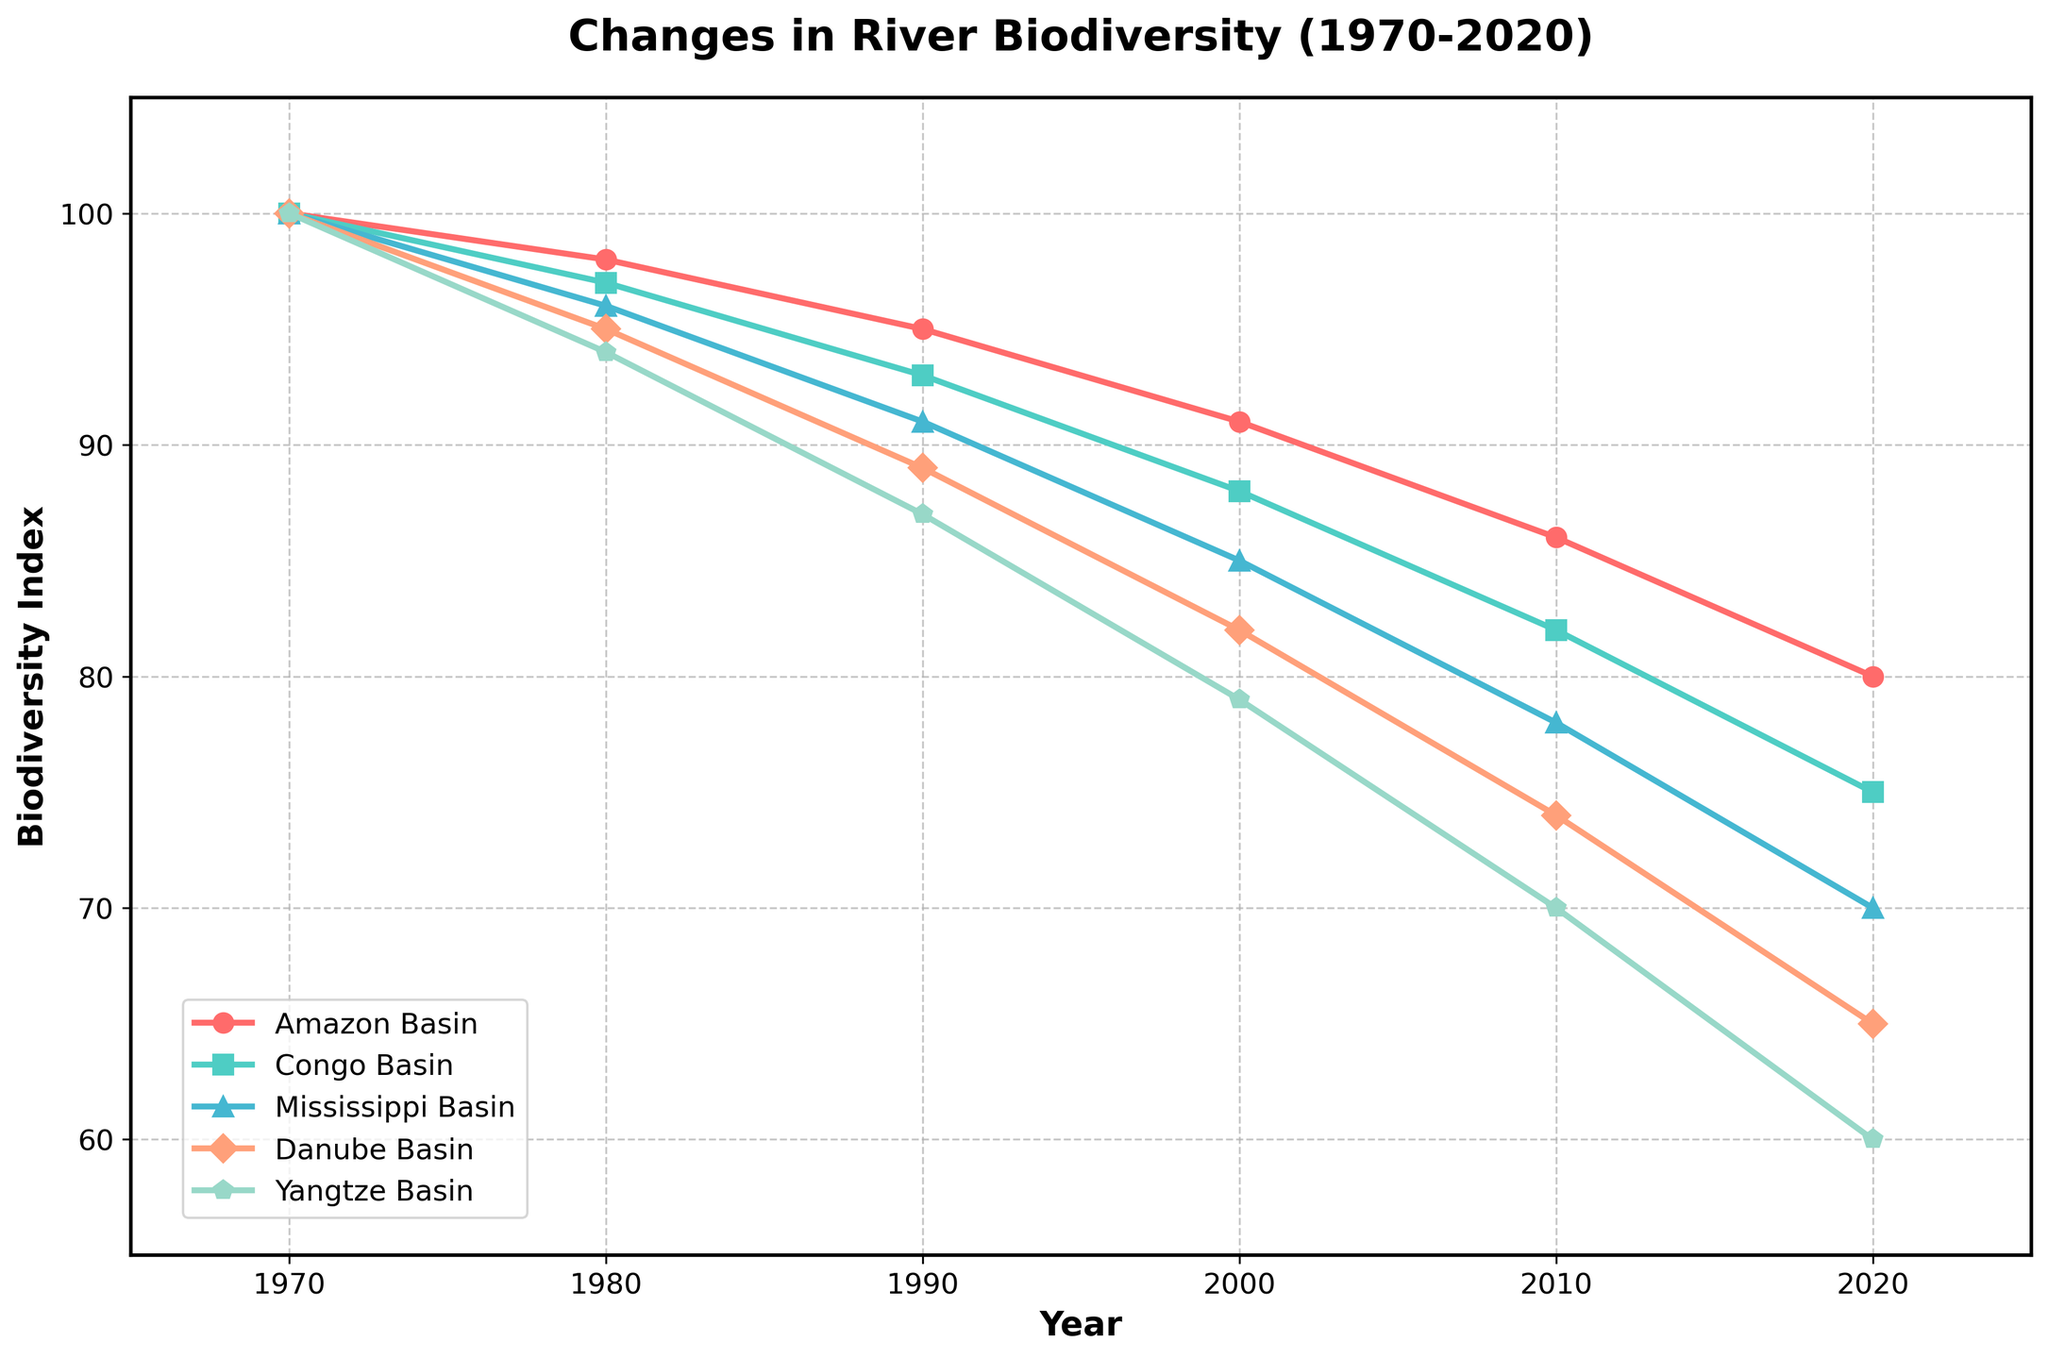How has the biodiversity index of the Amazon Basin changed from 1970 to 2020? The biodiversity index of the Amazon Basin starts at 100 in 1970 and drops to 80 by 2020. The values can be observed directly from the figure, showing a decrease of 20 over the 50 years.
Answer: Decreased by 20 Which river basin experienced the largest decrease in biodiversity over the last 50 years? To find the largest decrease, compare the 1970 and 2020 values for each river basin. The Amazon Basin decreased from 100 to 80, the Congo Basin from 100 to 75, the Mississippi Basin from 100 to 70, the Danube Basin from 100 to 65, and the Yangtze Basin from 100 to 60. The Yangtze Basin has the largest decrease (40).
Answer: Yangtze Basin Between which years did the Congo Basin's biodiversity index experience its steepest decline? To determine the steepest decline, calculate the differences between consecutive years for the Congo Basin: 100 to 97 (-3), 97 to 93 (-4), 93 to 88 (-5), 88 to 82 (-6), 82 to 75 (-7). The steepest decline happened between 2010 and 2020 (-7).
Answer: 2010 to 2020 Which river basin had the highest biodiversity index in 1990? To find this, check the biodiversity indexes for 1990. Amazon Basin (95), Congo Basin (93), Mississippi Basin (91), Danube Basin (89), and Yangtze Basin (87). The Amazon Basin had the highest index (95).
Answer: Amazon Basin On average, how much did the biodiversity index of the Danube Basin decrease each decade? Compute the total decrease from 1970 to 2020 for the Danube Basin: from 100 to 65, a decrease of 35 points. Over 5 decades, the average decrease per decade is 35 / 5 = 7.
Answer: 7 By what percentage did the biodiversity index of the Yangtze Basin decrease from 1970 to 2020? Calculate the percentage decrease with the formula [(initial value - final value) / initial value] * 100. For the Yangtze Basin: [(100 - 60) / 100] * 100 = 40%.
Answer: 40% During which decade did the Mississippi Basin experience the smallest decrease in biodiversity? Calculate the decreases: 100 to 96 (-4), 96 to 91 (-5), 91 to 85 (-6), 85 to 78 (-7), 78 to 70 (-8). The smallest decrease was between 1970 and 1980 (-4 points).
Answer: 1970 to 1980 How did the biodiversity index of the Congo and Danube Basins compare in 2010? Compare the values for both river basins in 2010: Congo Basin (82) and Danube Basin (74). The Congo Basin had a higher biodiversity index.
Answer: Congo Basin had a higher index What is the combined biodiversity index of the Amazon and Mississippi Basins in 2020? Add the biodiversity index values for both basins in 2020: Amazon Basin (80) + Mississippi Basin (70) = 150.
Answer: 150 